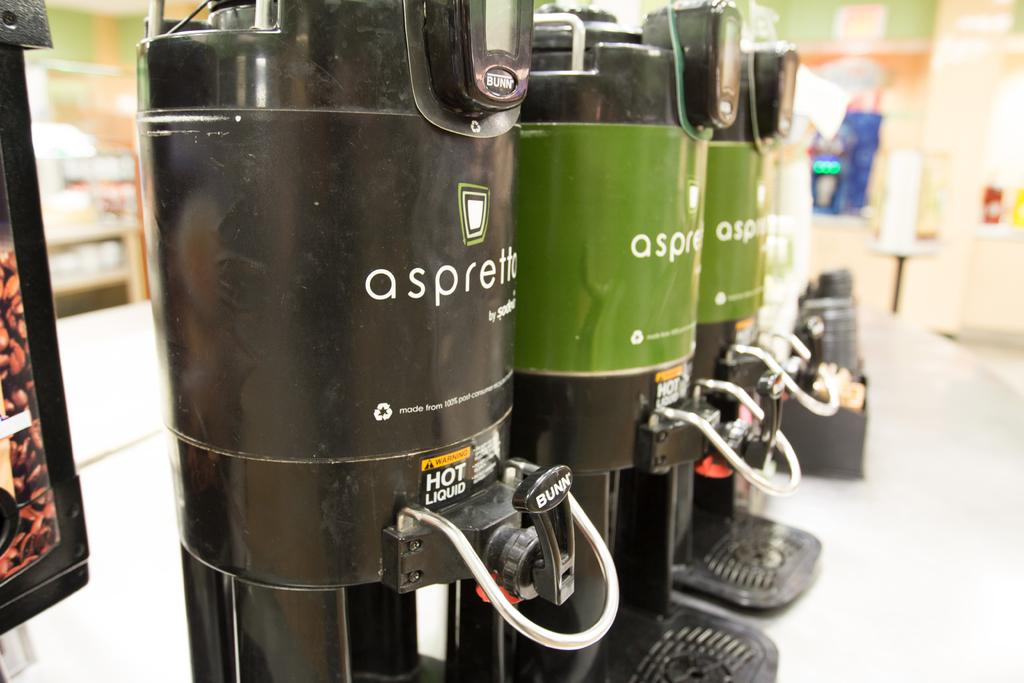What type of machines are visible in the image? The machines in the image resemble coffee machines. How are the coffee machines arranged in the image? The machines are arranged in a line. What is present at the bottom of the image? There is a table at the bottom of the image. What type of establishment might the image depict? The setting appears to be a coffee shop. What color is the gold thread used to decorate the playground in the image? There is no playground or gold thread present in the image. 